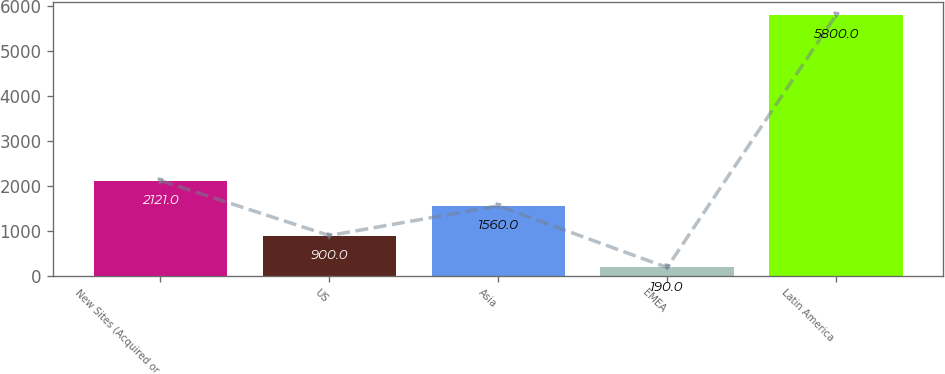Convert chart. <chart><loc_0><loc_0><loc_500><loc_500><bar_chart><fcel>New Sites (Acquired or<fcel>US<fcel>Asia<fcel>EMEA<fcel>Latin America<nl><fcel>2121<fcel>900<fcel>1560<fcel>190<fcel>5800<nl></chart> 